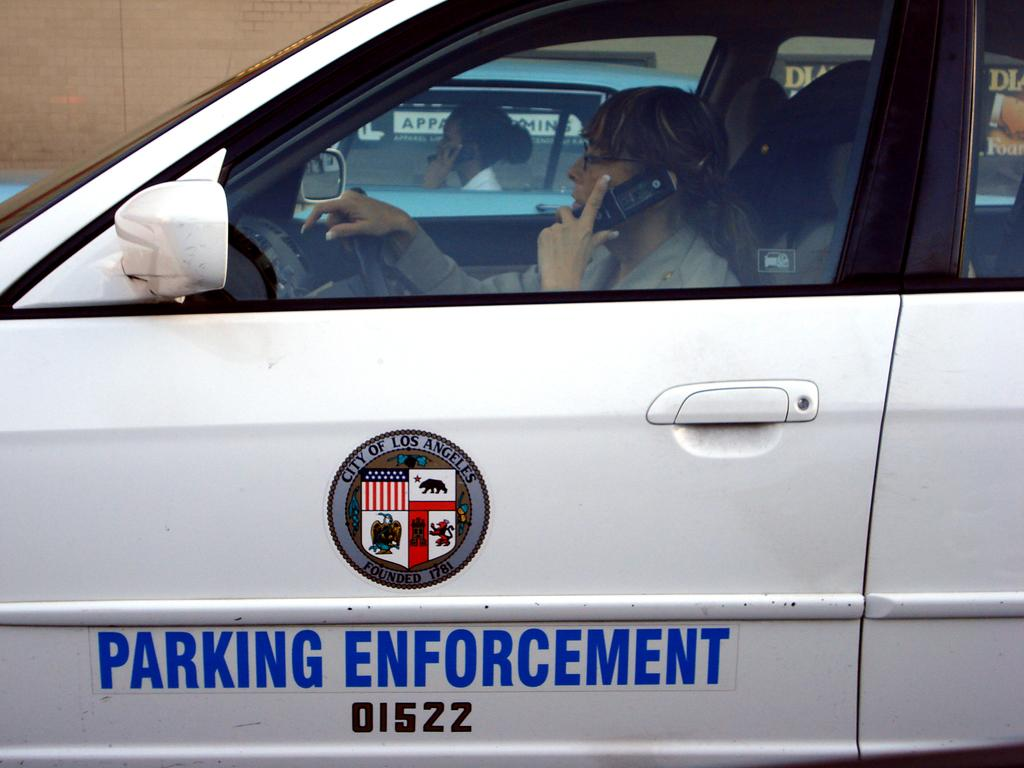What type of vehicle is in the image? There is a police car in the image. Who is driving the police car? An officer is driving the police car. What is the officer doing while driving? The officer is talking on the phone. What else can be seen in the image? There is another car in the image. Who is in the other car? A lady is in the other car. What is the lady doing in the car? The lady is talking on the phone. How does the officer tie a knot with the phone while driving? The officer is not tying a knot with the phone; they are simply talking on the phone while driving the police car. 